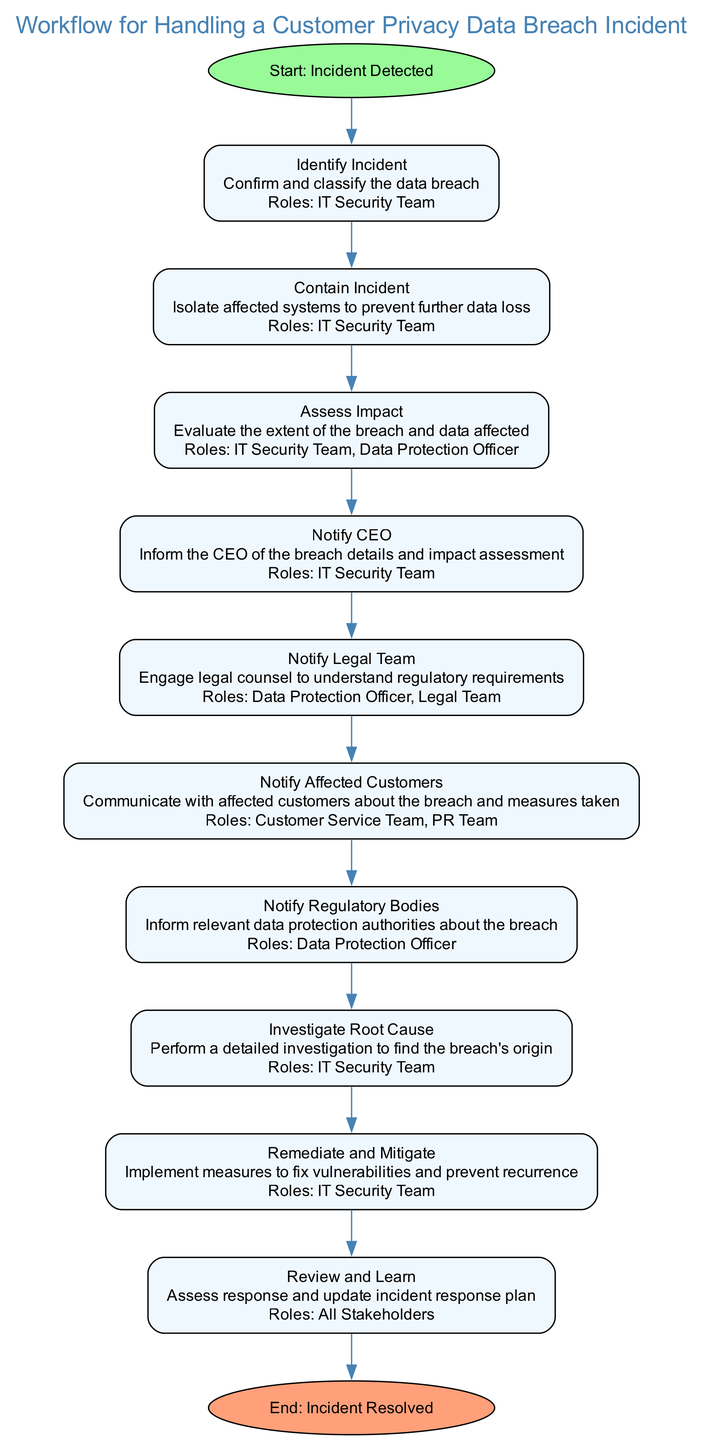What is the starting point of the workflow? The starting point of the workflow is labeled "Incident Detected." This is the first node in the diagram, which indicates the initiation of the incident handling process.
Answer: Incident Detected How many main actions are there in the diagram? By counting the nodes between the "Start" and "End," we find there are 11 main actions listed, including the identification, containment, assessment, and other steps associated with a data breach incident.
Answer: 11 Which team is responsible for confirming and classifying the data breach? The role responsible for confirming and classifying the data breach is the "IT Security Team," as outlined in the "Identify Incident" step, which specifically mentions their involvement.
Answer: IT Security Team What happens after informing the CEO? After notifying the CEO, the next step in the workflow is to "Notify Legal Team." This indicates a sequential flow where engaging legal counsel follows the CEO being informed of the breach.
Answer: Notify Legal Team Which stakeholders are involved in the "Review and Learn" phase? The "Review and Learn" phase involves "All Stakeholders," as stated in the description of that particular step. This means everyone related to the incident response is expected to assess and update the response plan collaboratively.
Answer: All Stakeholders What is the final step in this workflow? The final step in the workflow is labeled "Incident Resolved," which indicates that once all actions have been completed, the incident handling process is concluded.
Answer: Incident Resolved What is the role of the Data Protection Officer in this workflow? The "Data Protection Officer" plays multiple roles, including "Notify Legal Team" and "Notify Regulatory Bodies," indicating their involvement in compliance and legal proceedings following the breach.
Answer: Notify Legal Team, Notify Regulatory Bodies How does the workflow demonstrate the importance of notifying affected customers? The workflow includes the "Notify Affected Customers" step specifically, which emphasizes the importance of communication and transparency with customers impacted by the breach, demonstrating a commitment to customer care.
Answer: Notify Affected Customers What does the diagram suggest happens after assessing impact? After assessing the impact, the workflow suggests that the next action is to "Notify CEO," indicating that an assessment leads to briefing the leadership about the situation and its effects.
Answer: Notify CEO 